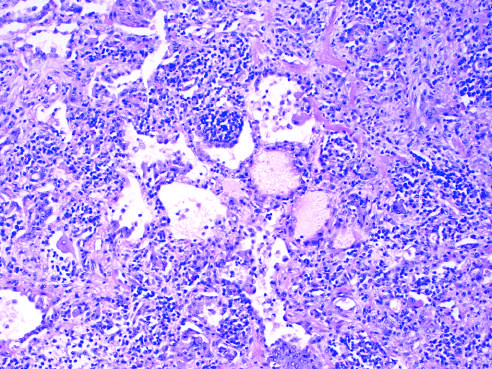what are the thickened alveolar walls infiltrated with?
Answer the question using a single word or phrase. Lymphocytes and some plasma cells 